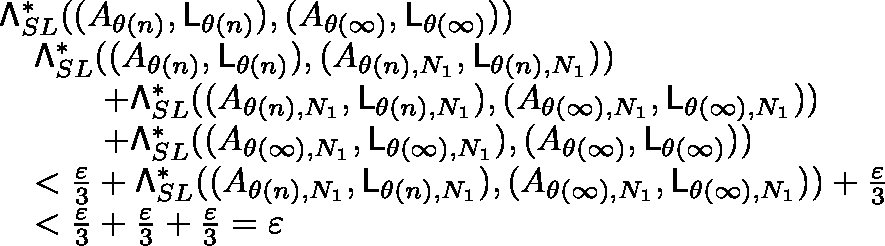<formula> <loc_0><loc_0><loc_500><loc_500>\begin{array} { r l } & { { \Lambda _ { S L } ^ { \ast } } ( ( { \mathfrak { A } } _ { \theta ( n ) } , { L } _ { \theta ( n ) } ) , ( { \mathfrak { A } } _ { \theta ( \infty ) } , { L } _ { \theta ( \infty ) } ) ) } \\ & { \quad \leqslant { \Lambda _ { S L } ^ { \ast } } ( ( { \mathfrak { A } } _ { \theta ( n ) } , { L } _ { \theta ( n ) } ) , ( { \mathfrak { A } } _ { \theta ( n ) , N _ { 1 } } , { L } _ { \theta ( n ) , N _ { 1 } } ) ) } \\ & { \quad + { \Lambda _ { S L } ^ { \ast } } ( ( { \mathfrak { A } } _ { \theta ( n ) , N _ { 1 } } , { L } _ { \theta ( n ) , N _ { 1 } } ) , ( { \mathfrak { A } } _ { \theta ( \infty ) , N _ { 1 } } , { L } _ { \theta ( \infty ) , N _ { 1 } } ) ) } \\ & { \quad + { \Lambda _ { S L } ^ { \ast } } ( ( { \mathfrak { A } } _ { \theta ( \infty ) , N _ { 1 } } , { L } _ { \theta ( \infty ) , N _ { 1 } } ) , ( { \mathfrak { A } } _ { \theta ( \infty ) } , { L } _ { \theta ( \infty ) } ) ) } \\ & { \quad < \frac { \varepsilon } { 3 } + { \Lambda _ { S L } ^ { \ast } } ( ( { \mathfrak { A } } _ { \theta ( n ) , N _ { 1 } } , { L } _ { \theta ( n ) , N _ { 1 } } ) , ( { \mathfrak { A } } _ { \theta ( \infty ) , N _ { 1 } } , { L } _ { \theta ( \infty ) , N _ { 1 } } ) ) + \frac { \varepsilon } { 3 } } \\ & { \quad < \frac { \varepsilon } { 3 } + \frac { \varepsilon } { 3 } + \frac { \varepsilon } { 3 } = \varepsilon } \end{array}</formula> 